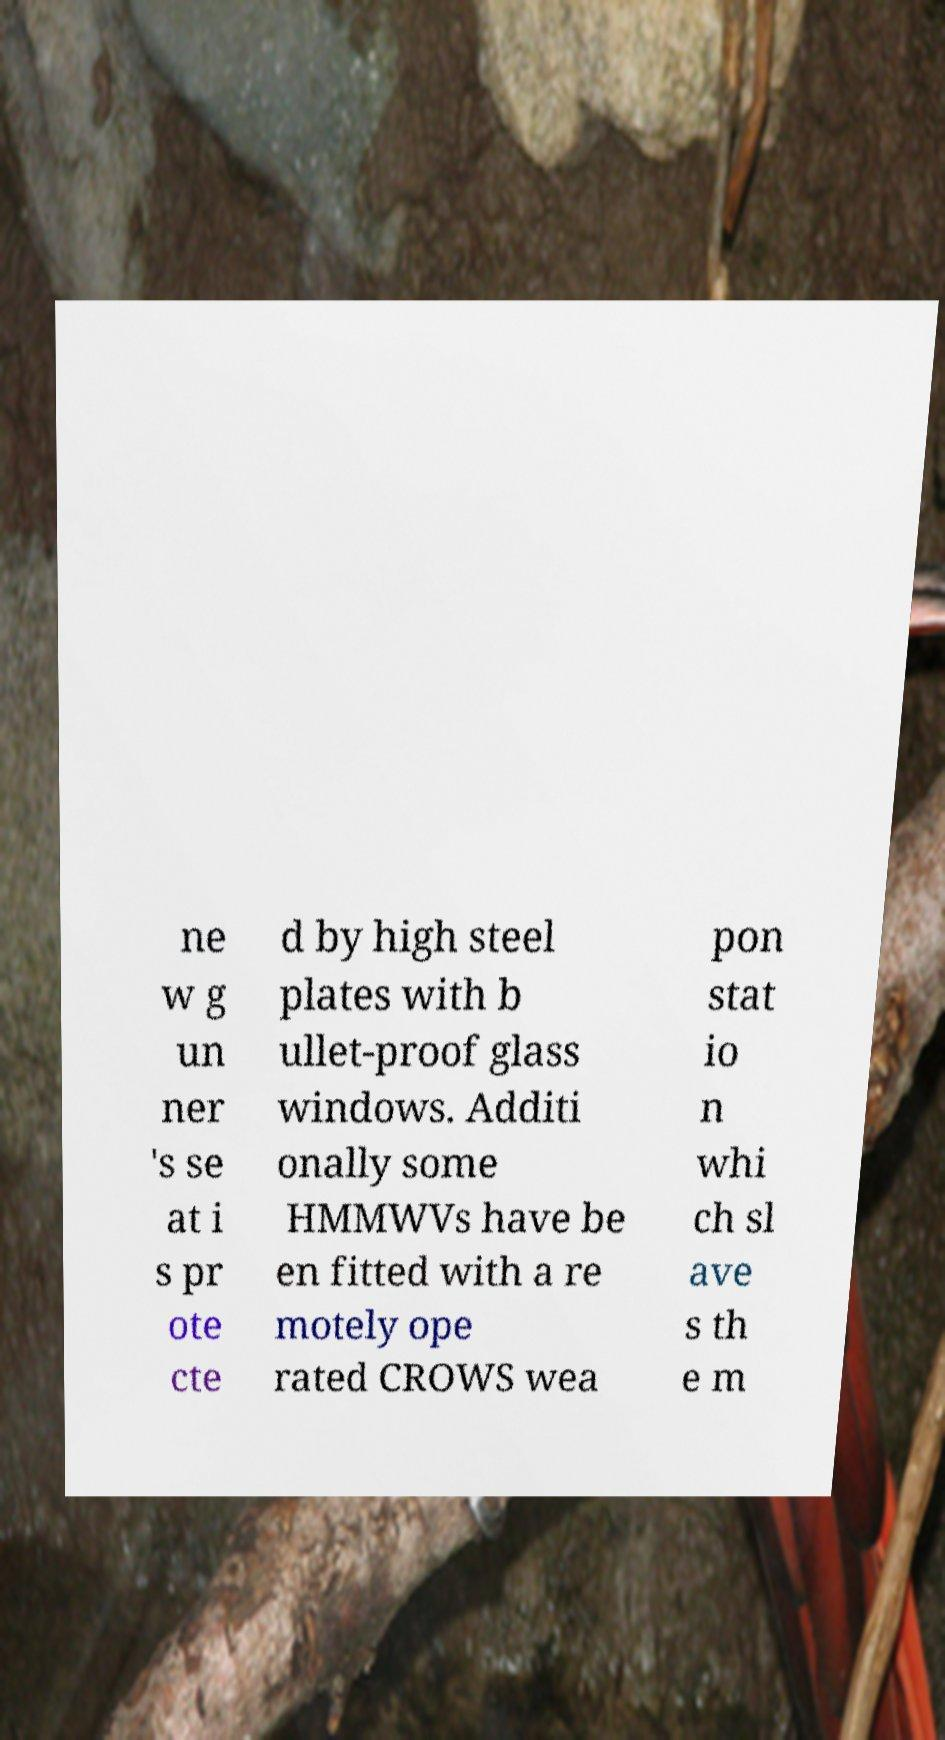What messages or text are displayed in this image? I need them in a readable, typed format. ne w g un ner 's se at i s pr ote cte d by high steel plates with b ullet-proof glass windows. Additi onally some HMMWVs have be en fitted with a re motely ope rated CROWS wea pon stat io n whi ch sl ave s th e m 